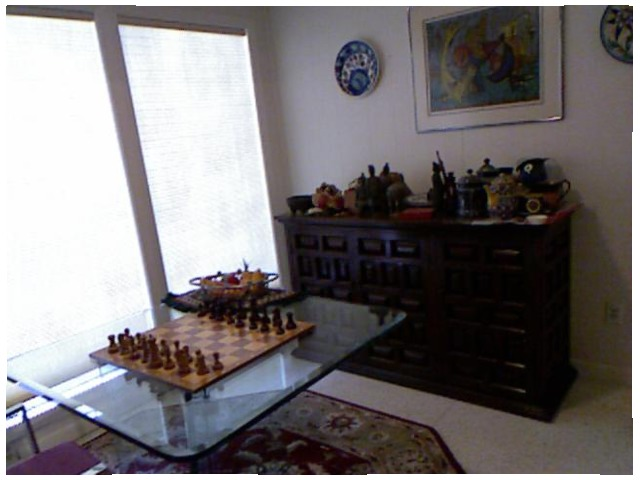<image>
Is there a picture on the floor? No. The picture is not positioned on the floor. They may be near each other, but the picture is not supported by or resting on top of the floor. Is there a dish behind the window? No. The dish is not behind the window. From this viewpoint, the dish appears to be positioned elsewhere in the scene. 